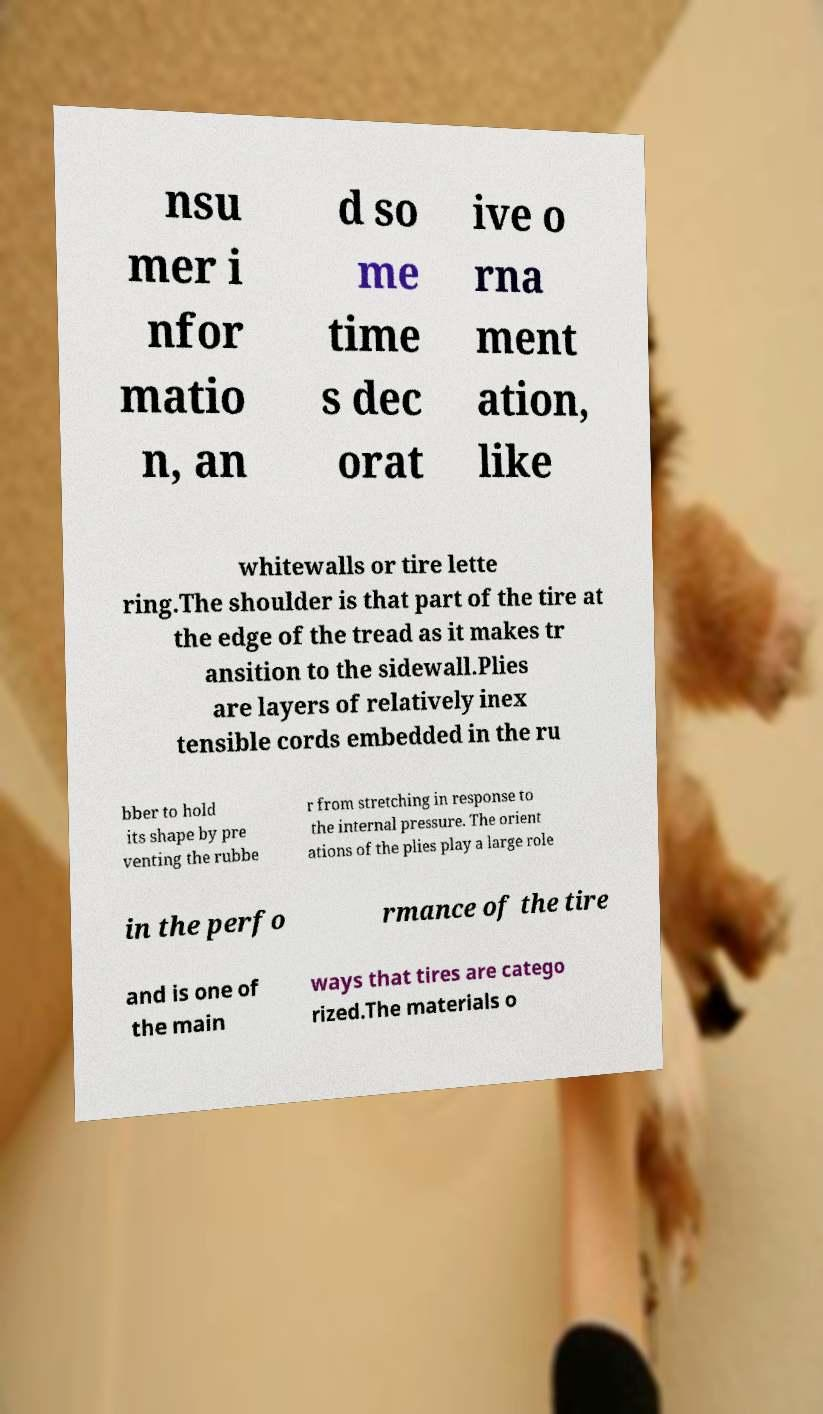For documentation purposes, I need the text within this image transcribed. Could you provide that? nsu mer i nfor matio n, an d so me time s dec orat ive o rna ment ation, like whitewalls or tire lette ring.The shoulder is that part of the tire at the edge of the tread as it makes tr ansition to the sidewall.Plies are layers of relatively inex tensible cords embedded in the ru bber to hold its shape by pre venting the rubbe r from stretching in response to the internal pressure. The orient ations of the plies play a large role in the perfo rmance of the tire and is one of the main ways that tires are catego rized.The materials o 